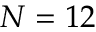Convert formula to latex. <formula><loc_0><loc_0><loc_500><loc_500>N = 1 2</formula> 